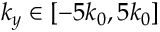<formula> <loc_0><loc_0><loc_500><loc_500>k _ { y } \in \left [ - 5 k _ { 0 } , 5 k _ { 0 } \right ]</formula> 